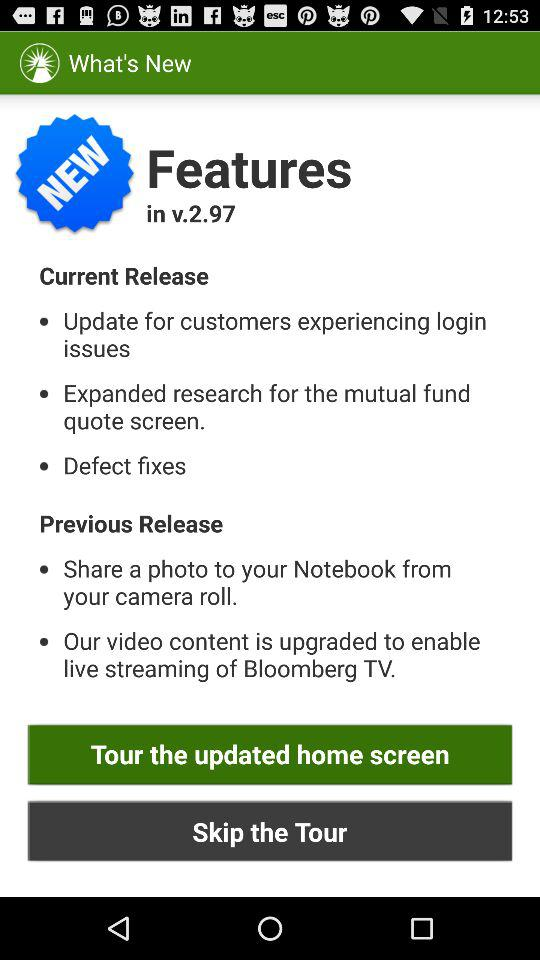What is the version? The version is v.2.97. 